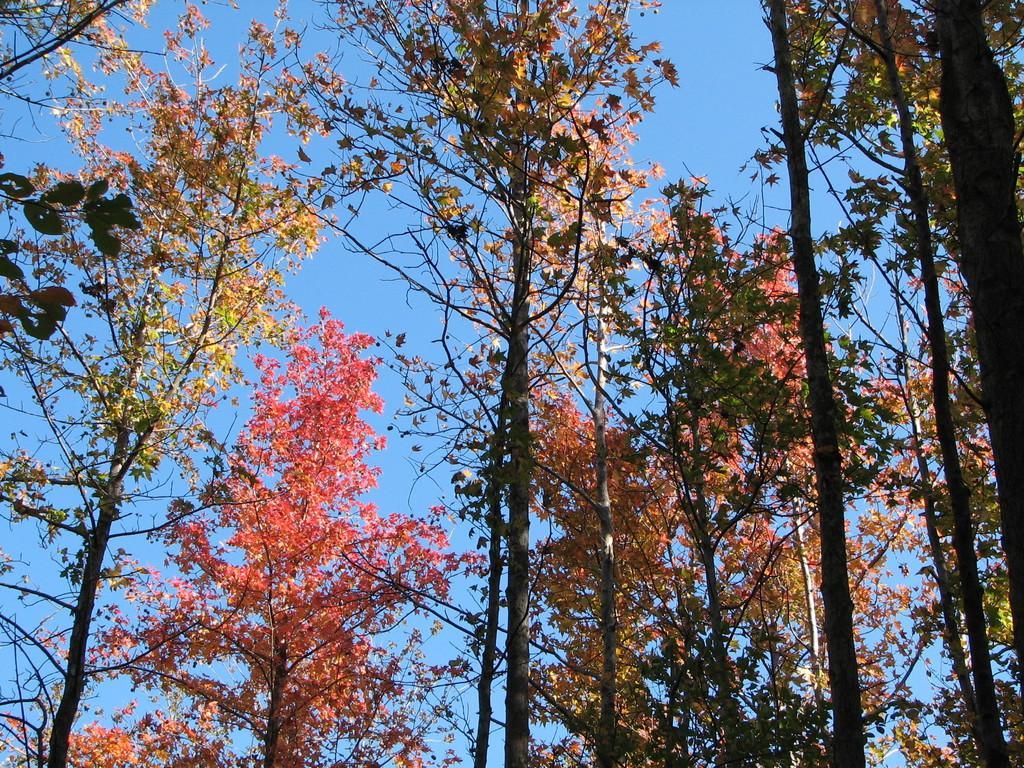Describe this image in one or two sentences. There are trees in this image, at the top it is the blue color sky. 